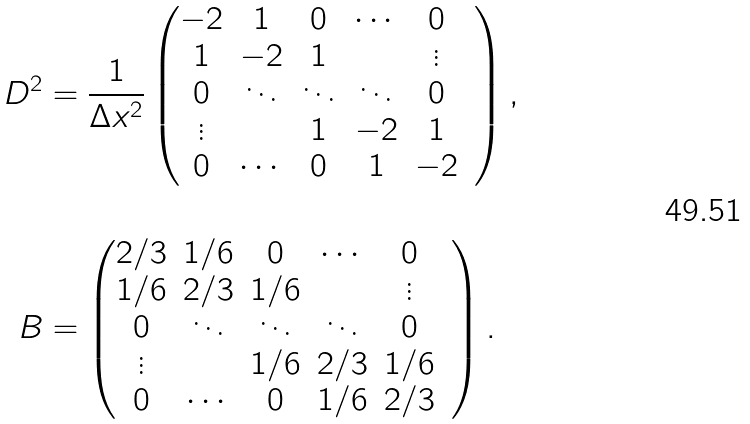Convert formula to latex. <formula><loc_0><loc_0><loc_500><loc_500>D ^ { 2 } & = \frac { 1 } { \Delta x ^ { 2 } } \begin{pmatrix} - 2 & 1 & 0 & \cdots & 0 \\ 1 & - 2 & 1 & & \vdots & \\ 0 & \ddots & \ddots & \ddots & 0 \\ \vdots & & 1 & - 2 & 1 \\ 0 & \cdots & 0 & 1 & - 2 \end{pmatrix} , \\ \\ B & = \begin{pmatrix} 2 / 3 & 1 / 6 & 0 & \cdots & 0 \\ 1 / 6 & 2 / 3 & 1 / 6 & & \vdots & \\ 0 & \ddots & \ddots & \ddots & 0 \\ \vdots & & 1 / 6 & 2 / 3 & 1 / 6 \\ 0 & \cdots & 0 & 1 / 6 & 2 / 3 \end{pmatrix} .</formula> 